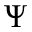<formula> <loc_0><loc_0><loc_500><loc_500>\Psi</formula> 